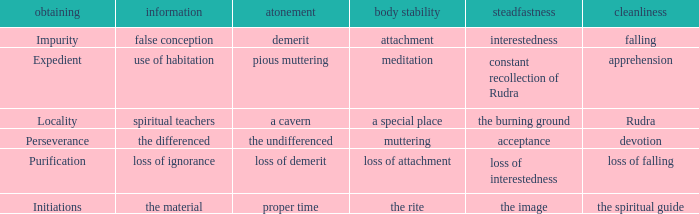 what's the constancy where permanence of the body is meditation Constant recollection of rudra. 